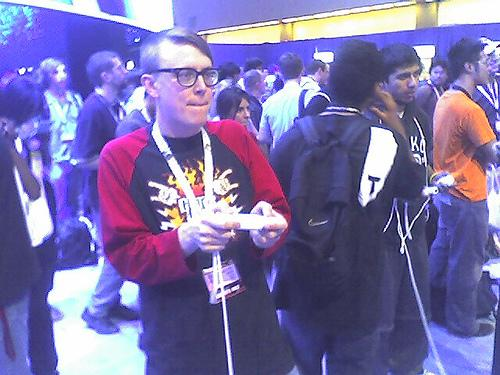What is the man in the black glasses using the white remote to do? play game 